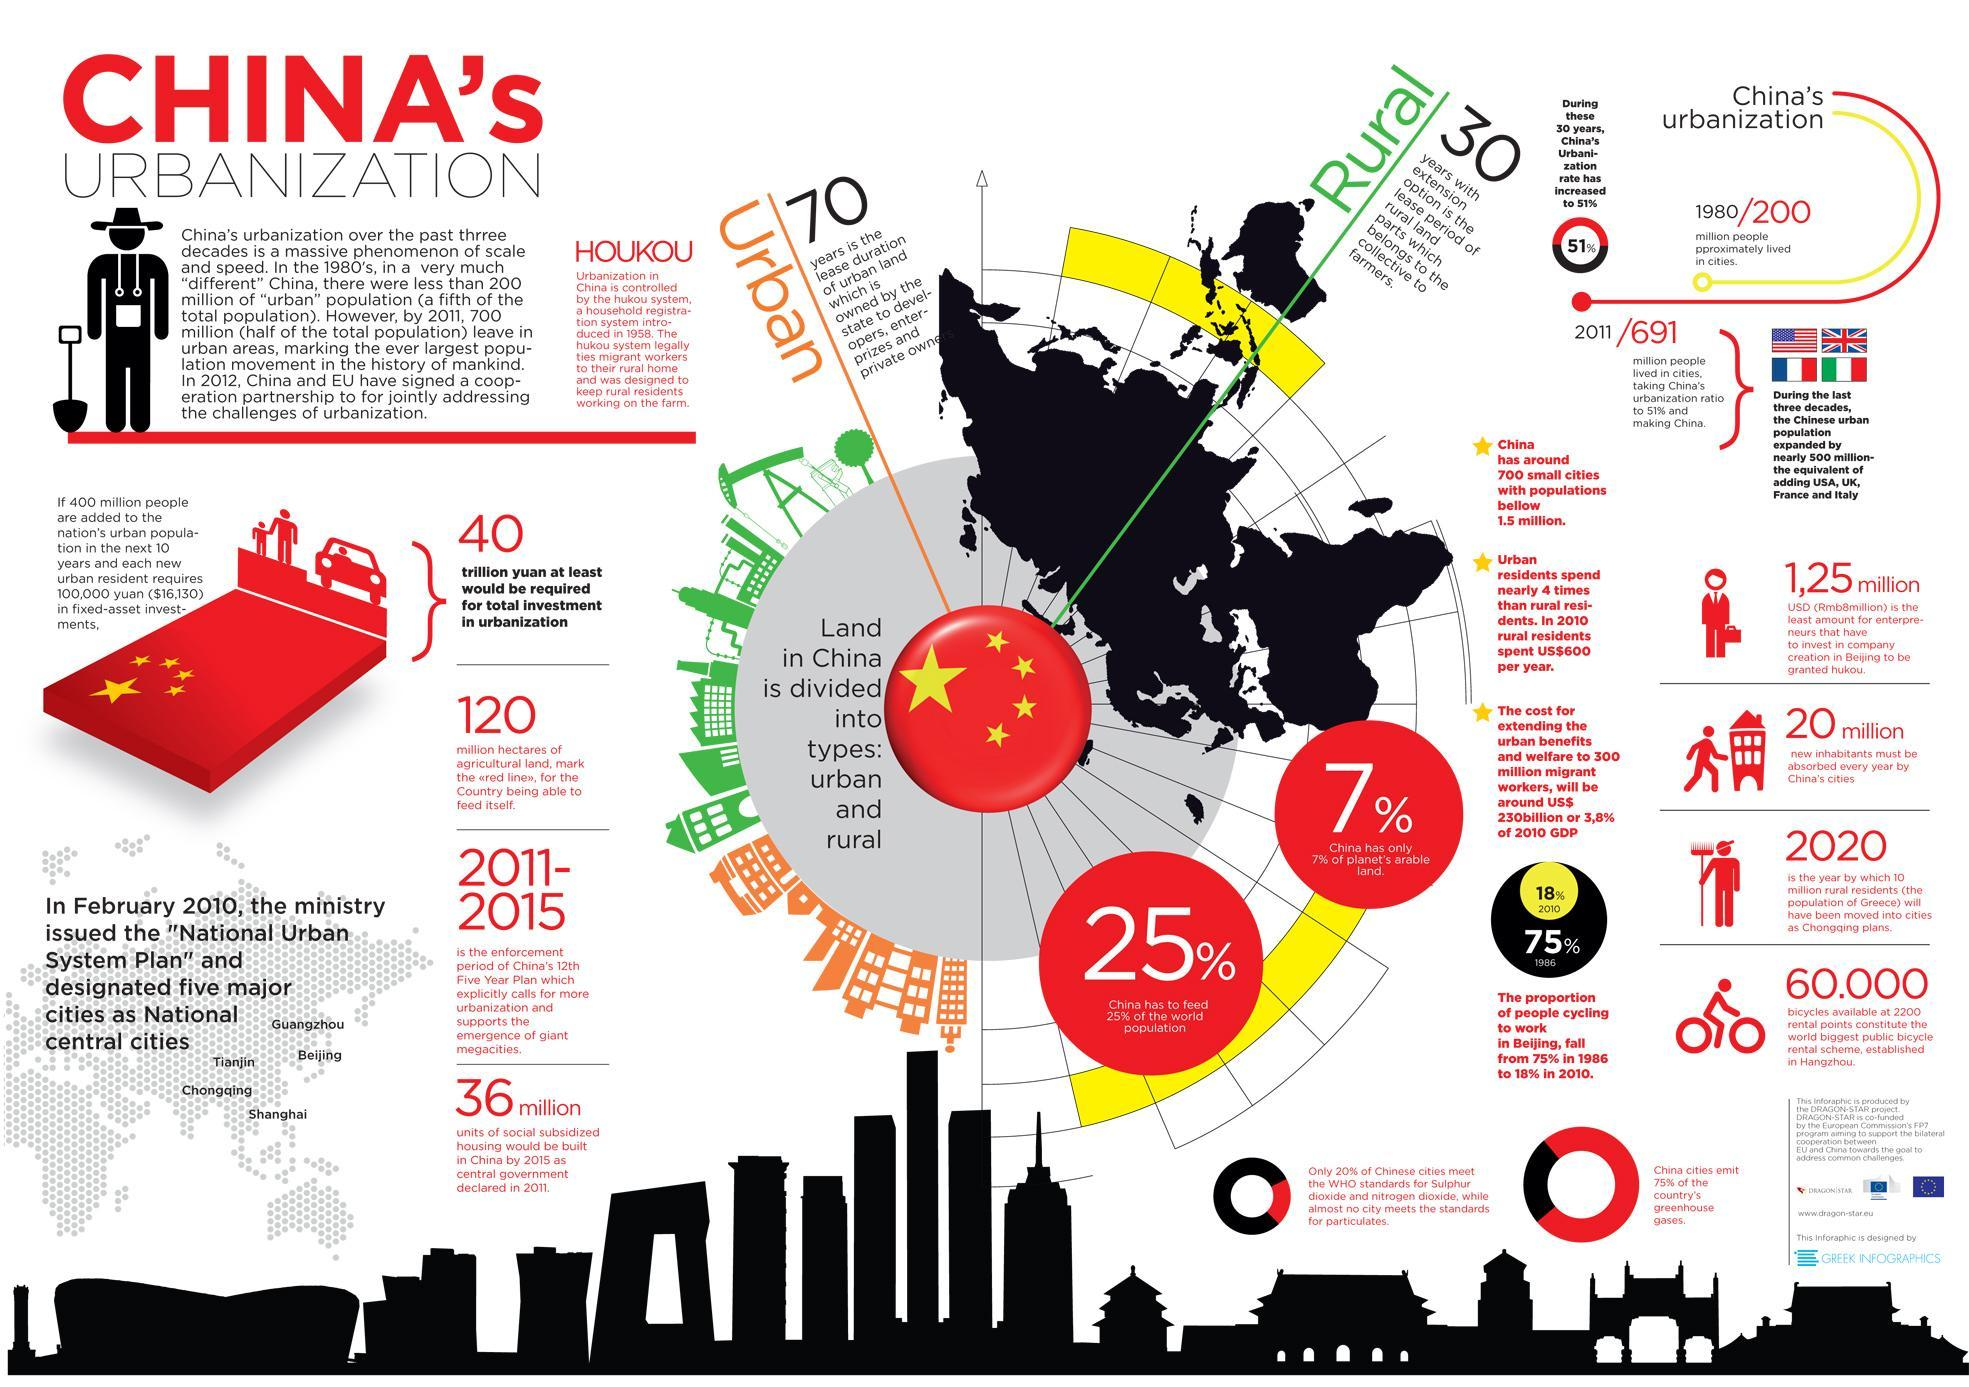What percentage of the world population is not fed by china?
Answer the question with a short phrase. 75% What percentage of the planet's arable land is not in China? 93% 